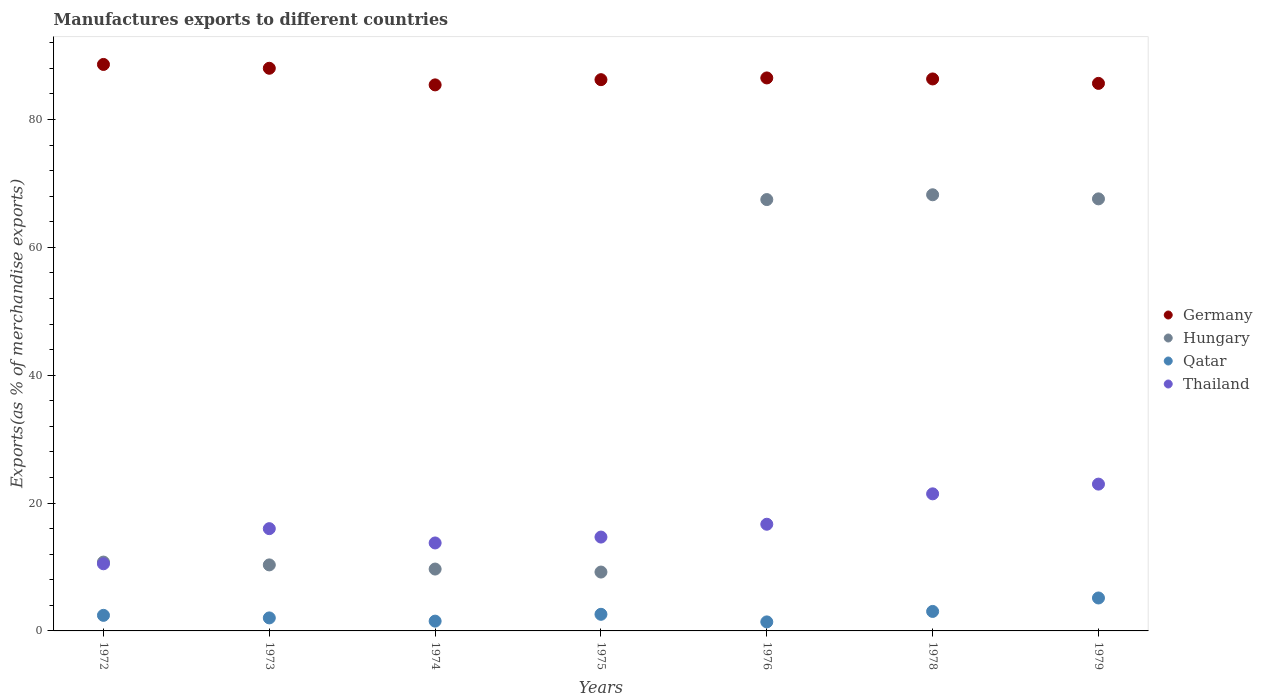Is the number of dotlines equal to the number of legend labels?
Provide a succinct answer. Yes. What is the percentage of exports to different countries in Hungary in 1978?
Ensure brevity in your answer.  68.23. Across all years, what is the maximum percentage of exports to different countries in Thailand?
Make the answer very short. 22.96. Across all years, what is the minimum percentage of exports to different countries in Thailand?
Make the answer very short. 10.5. In which year was the percentage of exports to different countries in Thailand maximum?
Your answer should be very brief. 1979. In which year was the percentage of exports to different countries in Germany minimum?
Your response must be concise. 1974. What is the total percentage of exports to different countries in Hungary in the graph?
Make the answer very short. 243.27. What is the difference between the percentage of exports to different countries in Thailand in 1972 and that in 1976?
Offer a very short reply. -6.18. What is the difference between the percentage of exports to different countries in Qatar in 1976 and the percentage of exports to different countries in Germany in 1974?
Provide a short and direct response. -84.01. What is the average percentage of exports to different countries in Thailand per year?
Make the answer very short. 16.58. In the year 1973, what is the difference between the percentage of exports to different countries in Thailand and percentage of exports to different countries in Germany?
Ensure brevity in your answer.  -72.02. What is the ratio of the percentage of exports to different countries in Hungary in 1972 to that in 1978?
Offer a terse response. 0.16. Is the percentage of exports to different countries in Hungary in 1973 less than that in 1978?
Your response must be concise. Yes. Is the difference between the percentage of exports to different countries in Thailand in 1973 and 1974 greater than the difference between the percentage of exports to different countries in Germany in 1973 and 1974?
Your response must be concise. No. What is the difference between the highest and the second highest percentage of exports to different countries in Thailand?
Keep it short and to the point. 1.52. What is the difference between the highest and the lowest percentage of exports to different countries in Hungary?
Your answer should be very brief. 59.02. In how many years, is the percentage of exports to different countries in Germany greater than the average percentage of exports to different countries in Germany taken over all years?
Your answer should be compact. 2. Is it the case that in every year, the sum of the percentage of exports to different countries in Thailand and percentage of exports to different countries in Germany  is greater than the sum of percentage of exports to different countries in Hungary and percentage of exports to different countries in Qatar?
Your answer should be very brief. No. Is the percentage of exports to different countries in Germany strictly greater than the percentage of exports to different countries in Qatar over the years?
Your answer should be very brief. Yes. What is the difference between two consecutive major ticks on the Y-axis?
Provide a short and direct response. 20. Are the values on the major ticks of Y-axis written in scientific E-notation?
Offer a terse response. No. Does the graph contain grids?
Provide a succinct answer. No. How many legend labels are there?
Keep it short and to the point. 4. How are the legend labels stacked?
Offer a very short reply. Vertical. What is the title of the graph?
Provide a short and direct response. Manufactures exports to different countries. Does "Greenland" appear as one of the legend labels in the graph?
Keep it short and to the point. No. What is the label or title of the X-axis?
Your response must be concise. Years. What is the label or title of the Y-axis?
Offer a very short reply. Exports(as % of merchandise exports). What is the Exports(as % of merchandise exports) of Germany in 1972?
Offer a terse response. 88.61. What is the Exports(as % of merchandise exports) in Hungary in 1972?
Offer a very short reply. 10.77. What is the Exports(as % of merchandise exports) of Qatar in 1972?
Keep it short and to the point. 2.44. What is the Exports(as % of merchandise exports) in Thailand in 1972?
Ensure brevity in your answer.  10.5. What is the Exports(as % of merchandise exports) of Germany in 1973?
Provide a short and direct response. 88.02. What is the Exports(as % of merchandise exports) in Hungary in 1973?
Provide a succinct answer. 10.33. What is the Exports(as % of merchandise exports) in Qatar in 1973?
Give a very brief answer. 2.04. What is the Exports(as % of merchandise exports) in Thailand in 1973?
Offer a terse response. 16. What is the Exports(as % of merchandise exports) in Germany in 1974?
Keep it short and to the point. 85.42. What is the Exports(as % of merchandise exports) in Hungary in 1974?
Your answer should be compact. 9.68. What is the Exports(as % of merchandise exports) in Qatar in 1974?
Provide a short and direct response. 1.53. What is the Exports(as % of merchandise exports) in Thailand in 1974?
Make the answer very short. 13.76. What is the Exports(as % of merchandise exports) of Germany in 1975?
Offer a terse response. 86.23. What is the Exports(as % of merchandise exports) of Hungary in 1975?
Keep it short and to the point. 9.21. What is the Exports(as % of merchandise exports) of Qatar in 1975?
Your answer should be compact. 2.6. What is the Exports(as % of merchandise exports) in Thailand in 1975?
Your answer should be very brief. 14.68. What is the Exports(as % of merchandise exports) of Germany in 1976?
Provide a short and direct response. 86.5. What is the Exports(as % of merchandise exports) in Hungary in 1976?
Offer a very short reply. 67.48. What is the Exports(as % of merchandise exports) of Qatar in 1976?
Your response must be concise. 1.41. What is the Exports(as % of merchandise exports) in Thailand in 1976?
Make the answer very short. 16.69. What is the Exports(as % of merchandise exports) of Germany in 1978?
Keep it short and to the point. 86.35. What is the Exports(as % of merchandise exports) in Hungary in 1978?
Offer a very short reply. 68.23. What is the Exports(as % of merchandise exports) of Qatar in 1978?
Provide a succinct answer. 3.05. What is the Exports(as % of merchandise exports) of Thailand in 1978?
Offer a very short reply. 21.44. What is the Exports(as % of merchandise exports) in Germany in 1979?
Offer a very short reply. 85.65. What is the Exports(as % of merchandise exports) of Hungary in 1979?
Provide a succinct answer. 67.59. What is the Exports(as % of merchandise exports) in Qatar in 1979?
Provide a succinct answer. 5.15. What is the Exports(as % of merchandise exports) of Thailand in 1979?
Give a very brief answer. 22.96. Across all years, what is the maximum Exports(as % of merchandise exports) in Germany?
Provide a succinct answer. 88.61. Across all years, what is the maximum Exports(as % of merchandise exports) of Hungary?
Keep it short and to the point. 68.23. Across all years, what is the maximum Exports(as % of merchandise exports) in Qatar?
Your response must be concise. 5.15. Across all years, what is the maximum Exports(as % of merchandise exports) in Thailand?
Offer a very short reply. 22.96. Across all years, what is the minimum Exports(as % of merchandise exports) in Germany?
Provide a succinct answer. 85.42. Across all years, what is the minimum Exports(as % of merchandise exports) in Hungary?
Make the answer very short. 9.21. Across all years, what is the minimum Exports(as % of merchandise exports) of Qatar?
Give a very brief answer. 1.41. Across all years, what is the minimum Exports(as % of merchandise exports) in Thailand?
Your answer should be very brief. 10.5. What is the total Exports(as % of merchandise exports) of Germany in the graph?
Offer a terse response. 606.78. What is the total Exports(as % of merchandise exports) of Hungary in the graph?
Offer a very short reply. 243.27. What is the total Exports(as % of merchandise exports) of Qatar in the graph?
Provide a succinct answer. 18.21. What is the total Exports(as % of merchandise exports) in Thailand in the graph?
Ensure brevity in your answer.  116.04. What is the difference between the Exports(as % of merchandise exports) in Germany in 1972 and that in 1973?
Provide a succinct answer. 0.6. What is the difference between the Exports(as % of merchandise exports) in Hungary in 1972 and that in 1973?
Make the answer very short. 0.44. What is the difference between the Exports(as % of merchandise exports) in Qatar in 1972 and that in 1973?
Your answer should be very brief. 0.4. What is the difference between the Exports(as % of merchandise exports) of Thailand in 1972 and that in 1973?
Offer a terse response. -5.5. What is the difference between the Exports(as % of merchandise exports) of Germany in 1972 and that in 1974?
Keep it short and to the point. 3.2. What is the difference between the Exports(as % of merchandise exports) in Hungary in 1972 and that in 1974?
Ensure brevity in your answer.  1.09. What is the difference between the Exports(as % of merchandise exports) of Qatar in 1972 and that in 1974?
Make the answer very short. 0.9. What is the difference between the Exports(as % of merchandise exports) in Thailand in 1972 and that in 1974?
Your answer should be very brief. -3.26. What is the difference between the Exports(as % of merchandise exports) in Germany in 1972 and that in 1975?
Give a very brief answer. 2.38. What is the difference between the Exports(as % of merchandise exports) of Hungary in 1972 and that in 1975?
Ensure brevity in your answer.  1.56. What is the difference between the Exports(as % of merchandise exports) in Qatar in 1972 and that in 1975?
Make the answer very short. -0.16. What is the difference between the Exports(as % of merchandise exports) of Thailand in 1972 and that in 1975?
Your answer should be compact. -4.18. What is the difference between the Exports(as % of merchandise exports) of Germany in 1972 and that in 1976?
Keep it short and to the point. 2.11. What is the difference between the Exports(as % of merchandise exports) of Hungary in 1972 and that in 1976?
Your response must be concise. -56.71. What is the difference between the Exports(as % of merchandise exports) in Qatar in 1972 and that in 1976?
Provide a short and direct response. 1.02. What is the difference between the Exports(as % of merchandise exports) in Thailand in 1972 and that in 1976?
Provide a succinct answer. -6.18. What is the difference between the Exports(as % of merchandise exports) of Germany in 1972 and that in 1978?
Keep it short and to the point. 2.27. What is the difference between the Exports(as % of merchandise exports) in Hungary in 1972 and that in 1978?
Make the answer very short. -57.46. What is the difference between the Exports(as % of merchandise exports) in Qatar in 1972 and that in 1978?
Make the answer very short. -0.61. What is the difference between the Exports(as % of merchandise exports) in Thailand in 1972 and that in 1978?
Offer a terse response. -10.94. What is the difference between the Exports(as % of merchandise exports) in Germany in 1972 and that in 1979?
Your answer should be very brief. 2.96. What is the difference between the Exports(as % of merchandise exports) in Hungary in 1972 and that in 1979?
Offer a terse response. -56.82. What is the difference between the Exports(as % of merchandise exports) in Qatar in 1972 and that in 1979?
Give a very brief answer. -2.72. What is the difference between the Exports(as % of merchandise exports) in Thailand in 1972 and that in 1979?
Your answer should be very brief. -12.46. What is the difference between the Exports(as % of merchandise exports) in Germany in 1973 and that in 1974?
Offer a terse response. 2.6. What is the difference between the Exports(as % of merchandise exports) in Hungary in 1973 and that in 1974?
Provide a succinct answer. 0.65. What is the difference between the Exports(as % of merchandise exports) of Qatar in 1973 and that in 1974?
Ensure brevity in your answer.  0.5. What is the difference between the Exports(as % of merchandise exports) in Thailand in 1973 and that in 1974?
Ensure brevity in your answer.  2.24. What is the difference between the Exports(as % of merchandise exports) of Germany in 1973 and that in 1975?
Your response must be concise. 1.78. What is the difference between the Exports(as % of merchandise exports) of Hungary in 1973 and that in 1975?
Make the answer very short. 1.12. What is the difference between the Exports(as % of merchandise exports) in Qatar in 1973 and that in 1975?
Provide a succinct answer. -0.56. What is the difference between the Exports(as % of merchandise exports) of Thailand in 1973 and that in 1975?
Keep it short and to the point. 1.32. What is the difference between the Exports(as % of merchandise exports) of Germany in 1973 and that in 1976?
Your response must be concise. 1.51. What is the difference between the Exports(as % of merchandise exports) in Hungary in 1973 and that in 1976?
Your answer should be compact. -57.15. What is the difference between the Exports(as % of merchandise exports) of Qatar in 1973 and that in 1976?
Make the answer very short. 0.62. What is the difference between the Exports(as % of merchandise exports) in Thailand in 1973 and that in 1976?
Offer a very short reply. -0.69. What is the difference between the Exports(as % of merchandise exports) in Germany in 1973 and that in 1978?
Keep it short and to the point. 1.67. What is the difference between the Exports(as % of merchandise exports) of Hungary in 1973 and that in 1978?
Your answer should be very brief. -57.9. What is the difference between the Exports(as % of merchandise exports) of Qatar in 1973 and that in 1978?
Your answer should be compact. -1.01. What is the difference between the Exports(as % of merchandise exports) in Thailand in 1973 and that in 1978?
Offer a very short reply. -5.45. What is the difference between the Exports(as % of merchandise exports) in Germany in 1973 and that in 1979?
Your answer should be compact. 2.36. What is the difference between the Exports(as % of merchandise exports) of Hungary in 1973 and that in 1979?
Make the answer very short. -57.26. What is the difference between the Exports(as % of merchandise exports) of Qatar in 1973 and that in 1979?
Offer a terse response. -3.12. What is the difference between the Exports(as % of merchandise exports) of Thailand in 1973 and that in 1979?
Offer a terse response. -6.97. What is the difference between the Exports(as % of merchandise exports) in Germany in 1974 and that in 1975?
Ensure brevity in your answer.  -0.81. What is the difference between the Exports(as % of merchandise exports) of Hungary in 1974 and that in 1975?
Provide a succinct answer. 0.47. What is the difference between the Exports(as % of merchandise exports) of Qatar in 1974 and that in 1975?
Offer a terse response. -1.07. What is the difference between the Exports(as % of merchandise exports) of Thailand in 1974 and that in 1975?
Your answer should be very brief. -0.92. What is the difference between the Exports(as % of merchandise exports) of Germany in 1974 and that in 1976?
Keep it short and to the point. -1.09. What is the difference between the Exports(as % of merchandise exports) in Hungary in 1974 and that in 1976?
Ensure brevity in your answer.  -57.8. What is the difference between the Exports(as % of merchandise exports) of Qatar in 1974 and that in 1976?
Your response must be concise. 0.12. What is the difference between the Exports(as % of merchandise exports) of Thailand in 1974 and that in 1976?
Your answer should be very brief. -2.93. What is the difference between the Exports(as % of merchandise exports) in Germany in 1974 and that in 1978?
Provide a short and direct response. -0.93. What is the difference between the Exports(as % of merchandise exports) of Hungary in 1974 and that in 1978?
Provide a succinct answer. -58.55. What is the difference between the Exports(as % of merchandise exports) in Qatar in 1974 and that in 1978?
Offer a very short reply. -1.52. What is the difference between the Exports(as % of merchandise exports) of Thailand in 1974 and that in 1978?
Offer a terse response. -7.68. What is the difference between the Exports(as % of merchandise exports) of Germany in 1974 and that in 1979?
Provide a succinct answer. -0.23. What is the difference between the Exports(as % of merchandise exports) in Hungary in 1974 and that in 1979?
Provide a short and direct response. -57.91. What is the difference between the Exports(as % of merchandise exports) in Qatar in 1974 and that in 1979?
Provide a succinct answer. -3.62. What is the difference between the Exports(as % of merchandise exports) in Thailand in 1974 and that in 1979?
Ensure brevity in your answer.  -9.2. What is the difference between the Exports(as % of merchandise exports) of Germany in 1975 and that in 1976?
Ensure brevity in your answer.  -0.27. What is the difference between the Exports(as % of merchandise exports) of Hungary in 1975 and that in 1976?
Give a very brief answer. -58.27. What is the difference between the Exports(as % of merchandise exports) of Qatar in 1975 and that in 1976?
Your response must be concise. 1.19. What is the difference between the Exports(as % of merchandise exports) in Thailand in 1975 and that in 1976?
Your response must be concise. -2.01. What is the difference between the Exports(as % of merchandise exports) in Germany in 1975 and that in 1978?
Provide a succinct answer. -0.11. What is the difference between the Exports(as % of merchandise exports) in Hungary in 1975 and that in 1978?
Keep it short and to the point. -59.02. What is the difference between the Exports(as % of merchandise exports) in Qatar in 1975 and that in 1978?
Offer a very short reply. -0.45. What is the difference between the Exports(as % of merchandise exports) of Thailand in 1975 and that in 1978?
Your response must be concise. -6.76. What is the difference between the Exports(as % of merchandise exports) of Germany in 1975 and that in 1979?
Provide a short and direct response. 0.58. What is the difference between the Exports(as % of merchandise exports) in Hungary in 1975 and that in 1979?
Give a very brief answer. -58.38. What is the difference between the Exports(as % of merchandise exports) in Qatar in 1975 and that in 1979?
Offer a terse response. -2.55. What is the difference between the Exports(as % of merchandise exports) in Thailand in 1975 and that in 1979?
Keep it short and to the point. -8.28. What is the difference between the Exports(as % of merchandise exports) of Germany in 1976 and that in 1978?
Offer a terse response. 0.16. What is the difference between the Exports(as % of merchandise exports) in Hungary in 1976 and that in 1978?
Offer a terse response. -0.75. What is the difference between the Exports(as % of merchandise exports) in Qatar in 1976 and that in 1978?
Offer a terse response. -1.64. What is the difference between the Exports(as % of merchandise exports) of Thailand in 1976 and that in 1978?
Offer a very short reply. -4.76. What is the difference between the Exports(as % of merchandise exports) in Germany in 1976 and that in 1979?
Your answer should be compact. 0.85. What is the difference between the Exports(as % of merchandise exports) of Hungary in 1976 and that in 1979?
Your response must be concise. -0.11. What is the difference between the Exports(as % of merchandise exports) of Qatar in 1976 and that in 1979?
Provide a succinct answer. -3.74. What is the difference between the Exports(as % of merchandise exports) of Thailand in 1976 and that in 1979?
Provide a succinct answer. -6.28. What is the difference between the Exports(as % of merchandise exports) in Germany in 1978 and that in 1979?
Offer a very short reply. 0.69. What is the difference between the Exports(as % of merchandise exports) in Hungary in 1978 and that in 1979?
Your response must be concise. 0.64. What is the difference between the Exports(as % of merchandise exports) in Qatar in 1978 and that in 1979?
Provide a succinct answer. -2.1. What is the difference between the Exports(as % of merchandise exports) of Thailand in 1978 and that in 1979?
Your answer should be very brief. -1.52. What is the difference between the Exports(as % of merchandise exports) in Germany in 1972 and the Exports(as % of merchandise exports) in Hungary in 1973?
Your answer should be very brief. 78.29. What is the difference between the Exports(as % of merchandise exports) of Germany in 1972 and the Exports(as % of merchandise exports) of Qatar in 1973?
Provide a short and direct response. 86.58. What is the difference between the Exports(as % of merchandise exports) of Germany in 1972 and the Exports(as % of merchandise exports) of Thailand in 1973?
Keep it short and to the point. 72.62. What is the difference between the Exports(as % of merchandise exports) of Hungary in 1972 and the Exports(as % of merchandise exports) of Qatar in 1973?
Give a very brief answer. 8.73. What is the difference between the Exports(as % of merchandise exports) in Hungary in 1972 and the Exports(as % of merchandise exports) in Thailand in 1973?
Your response must be concise. -5.23. What is the difference between the Exports(as % of merchandise exports) in Qatar in 1972 and the Exports(as % of merchandise exports) in Thailand in 1973?
Give a very brief answer. -13.56. What is the difference between the Exports(as % of merchandise exports) in Germany in 1972 and the Exports(as % of merchandise exports) in Hungary in 1974?
Your response must be concise. 78.94. What is the difference between the Exports(as % of merchandise exports) in Germany in 1972 and the Exports(as % of merchandise exports) in Qatar in 1974?
Offer a very short reply. 87.08. What is the difference between the Exports(as % of merchandise exports) in Germany in 1972 and the Exports(as % of merchandise exports) in Thailand in 1974?
Make the answer very short. 74.85. What is the difference between the Exports(as % of merchandise exports) of Hungary in 1972 and the Exports(as % of merchandise exports) of Qatar in 1974?
Give a very brief answer. 9.24. What is the difference between the Exports(as % of merchandise exports) of Hungary in 1972 and the Exports(as % of merchandise exports) of Thailand in 1974?
Provide a short and direct response. -2.99. What is the difference between the Exports(as % of merchandise exports) of Qatar in 1972 and the Exports(as % of merchandise exports) of Thailand in 1974?
Ensure brevity in your answer.  -11.32. What is the difference between the Exports(as % of merchandise exports) in Germany in 1972 and the Exports(as % of merchandise exports) in Hungary in 1975?
Provide a succinct answer. 79.41. What is the difference between the Exports(as % of merchandise exports) of Germany in 1972 and the Exports(as % of merchandise exports) of Qatar in 1975?
Ensure brevity in your answer.  86.02. What is the difference between the Exports(as % of merchandise exports) of Germany in 1972 and the Exports(as % of merchandise exports) of Thailand in 1975?
Make the answer very short. 73.93. What is the difference between the Exports(as % of merchandise exports) in Hungary in 1972 and the Exports(as % of merchandise exports) in Qatar in 1975?
Keep it short and to the point. 8.17. What is the difference between the Exports(as % of merchandise exports) in Hungary in 1972 and the Exports(as % of merchandise exports) in Thailand in 1975?
Ensure brevity in your answer.  -3.91. What is the difference between the Exports(as % of merchandise exports) of Qatar in 1972 and the Exports(as % of merchandise exports) of Thailand in 1975?
Your response must be concise. -12.25. What is the difference between the Exports(as % of merchandise exports) of Germany in 1972 and the Exports(as % of merchandise exports) of Hungary in 1976?
Your answer should be compact. 21.14. What is the difference between the Exports(as % of merchandise exports) of Germany in 1972 and the Exports(as % of merchandise exports) of Qatar in 1976?
Your answer should be very brief. 87.2. What is the difference between the Exports(as % of merchandise exports) in Germany in 1972 and the Exports(as % of merchandise exports) in Thailand in 1976?
Provide a short and direct response. 71.93. What is the difference between the Exports(as % of merchandise exports) in Hungary in 1972 and the Exports(as % of merchandise exports) in Qatar in 1976?
Provide a succinct answer. 9.36. What is the difference between the Exports(as % of merchandise exports) in Hungary in 1972 and the Exports(as % of merchandise exports) in Thailand in 1976?
Ensure brevity in your answer.  -5.92. What is the difference between the Exports(as % of merchandise exports) in Qatar in 1972 and the Exports(as % of merchandise exports) in Thailand in 1976?
Make the answer very short. -14.25. What is the difference between the Exports(as % of merchandise exports) of Germany in 1972 and the Exports(as % of merchandise exports) of Hungary in 1978?
Your answer should be compact. 20.39. What is the difference between the Exports(as % of merchandise exports) of Germany in 1972 and the Exports(as % of merchandise exports) of Qatar in 1978?
Give a very brief answer. 85.56. What is the difference between the Exports(as % of merchandise exports) of Germany in 1972 and the Exports(as % of merchandise exports) of Thailand in 1978?
Provide a succinct answer. 67.17. What is the difference between the Exports(as % of merchandise exports) in Hungary in 1972 and the Exports(as % of merchandise exports) in Qatar in 1978?
Provide a succinct answer. 7.72. What is the difference between the Exports(as % of merchandise exports) in Hungary in 1972 and the Exports(as % of merchandise exports) in Thailand in 1978?
Your answer should be compact. -10.68. What is the difference between the Exports(as % of merchandise exports) of Qatar in 1972 and the Exports(as % of merchandise exports) of Thailand in 1978?
Your response must be concise. -19.01. What is the difference between the Exports(as % of merchandise exports) in Germany in 1972 and the Exports(as % of merchandise exports) in Hungary in 1979?
Offer a terse response. 21.03. What is the difference between the Exports(as % of merchandise exports) of Germany in 1972 and the Exports(as % of merchandise exports) of Qatar in 1979?
Give a very brief answer. 83.46. What is the difference between the Exports(as % of merchandise exports) in Germany in 1972 and the Exports(as % of merchandise exports) in Thailand in 1979?
Your response must be concise. 65.65. What is the difference between the Exports(as % of merchandise exports) in Hungary in 1972 and the Exports(as % of merchandise exports) in Qatar in 1979?
Keep it short and to the point. 5.61. What is the difference between the Exports(as % of merchandise exports) of Hungary in 1972 and the Exports(as % of merchandise exports) of Thailand in 1979?
Provide a succinct answer. -12.2. What is the difference between the Exports(as % of merchandise exports) of Qatar in 1972 and the Exports(as % of merchandise exports) of Thailand in 1979?
Your answer should be compact. -20.53. What is the difference between the Exports(as % of merchandise exports) in Germany in 1973 and the Exports(as % of merchandise exports) in Hungary in 1974?
Make the answer very short. 78.34. What is the difference between the Exports(as % of merchandise exports) of Germany in 1973 and the Exports(as % of merchandise exports) of Qatar in 1974?
Offer a very short reply. 86.48. What is the difference between the Exports(as % of merchandise exports) of Germany in 1973 and the Exports(as % of merchandise exports) of Thailand in 1974?
Your answer should be compact. 74.26. What is the difference between the Exports(as % of merchandise exports) of Hungary in 1973 and the Exports(as % of merchandise exports) of Qatar in 1974?
Offer a terse response. 8.8. What is the difference between the Exports(as % of merchandise exports) in Hungary in 1973 and the Exports(as % of merchandise exports) in Thailand in 1974?
Keep it short and to the point. -3.43. What is the difference between the Exports(as % of merchandise exports) of Qatar in 1973 and the Exports(as % of merchandise exports) of Thailand in 1974?
Keep it short and to the point. -11.72. What is the difference between the Exports(as % of merchandise exports) of Germany in 1973 and the Exports(as % of merchandise exports) of Hungary in 1975?
Provide a succinct answer. 78.81. What is the difference between the Exports(as % of merchandise exports) in Germany in 1973 and the Exports(as % of merchandise exports) in Qatar in 1975?
Your answer should be very brief. 85.42. What is the difference between the Exports(as % of merchandise exports) in Germany in 1973 and the Exports(as % of merchandise exports) in Thailand in 1975?
Offer a very short reply. 73.33. What is the difference between the Exports(as % of merchandise exports) in Hungary in 1973 and the Exports(as % of merchandise exports) in Qatar in 1975?
Give a very brief answer. 7.73. What is the difference between the Exports(as % of merchandise exports) of Hungary in 1973 and the Exports(as % of merchandise exports) of Thailand in 1975?
Offer a very short reply. -4.35. What is the difference between the Exports(as % of merchandise exports) of Qatar in 1973 and the Exports(as % of merchandise exports) of Thailand in 1975?
Make the answer very short. -12.65. What is the difference between the Exports(as % of merchandise exports) in Germany in 1973 and the Exports(as % of merchandise exports) in Hungary in 1976?
Ensure brevity in your answer.  20.54. What is the difference between the Exports(as % of merchandise exports) of Germany in 1973 and the Exports(as % of merchandise exports) of Qatar in 1976?
Provide a short and direct response. 86.61. What is the difference between the Exports(as % of merchandise exports) of Germany in 1973 and the Exports(as % of merchandise exports) of Thailand in 1976?
Your response must be concise. 71.33. What is the difference between the Exports(as % of merchandise exports) of Hungary in 1973 and the Exports(as % of merchandise exports) of Qatar in 1976?
Keep it short and to the point. 8.92. What is the difference between the Exports(as % of merchandise exports) in Hungary in 1973 and the Exports(as % of merchandise exports) in Thailand in 1976?
Offer a terse response. -6.36. What is the difference between the Exports(as % of merchandise exports) in Qatar in 1973 and the Exports(as % of merchandise exports) in Thailand in 1976?
Provide a succinct answer. -14.65. What is the difference between the Exports(as % of merchandise exports) of Germany in 1973 and the Exports(as % of merchandise exports) of Hungary in 1978?
Your response must be concise. 19.79. What is the difference between the Exports(as % of merchandise exports) in Germany in 1973 and the Exports(as % of merchandise exports) in Qatar in 1978?
Your response must be concise. 84.97. What is the difference between the Exports(as % of merchandise exports) in Germany in 1973 and the Exports(as % of merchandise exports) in Thailand in 1978?
Your answer should be compact. 66.57. What is the difference between the Exports(as % of merchandise exports) in Hungary in 1973 and the Exports(as % of merchandise exports) in Qatar in 1978?
Ensure brevity in your answer.  7.28. What is the difference between the Exports(as % of merchandise exports) in Hungary in 1973 and the Exports(as % of merchandise exports) in Thailand in 1978?
Offer a very short reply. -11.12. What is the difference between the Exports(as % of merchandise exports) in Qatar in 1973 and the Exports(as % of merchandise exports) in Thailand in 1978?
Your answer should be very brief. -19.41. What is the difference between the Exports(as % of merchandise exports) in Germany in 1973 and the Exports(as % of merchandise exports) in Hungary in 1979?
Provide a succinct answer. 20.43. What is the difference between the Exports(as % of merchandise exports) of Germany in 1973 and the Exports(as % of merchandise exports) of Qatar in 1979?
Provide a succinct answer. 82.86. What is the difference between the Exports(as % of merchandise exports) of Germany in 1973 and the Exports(as % of merchandise exports) of Thailand in 1979?
Your answer should be compact. 65.05. What is the difference between the Exports(as % of merchandise exports) of Hungary in 1973 and the Exports(as % of merchandise exports) of Qatar in 1979?
Offer a terse response. 5.18. What is the difference between the Exports(as % of merchandise exports) in Hungary in 1973 and the Exports(as % of merchandise exports) in Thailand in 1979?
Your answer should be compact. -12.64. What is the difference between the Exports(as % of merchandise exports) in Qatar in 1973 and the Exports(as % of merchandise exports) in Thailand in 1979?
Make the answer very short. -20.93. What is the difference between the Exports(as % of merchandise exports) of Germany in 1974 and the Exports(as % of merchandise exports) of Hungary in 1975?
Ensure brevity in your answer.  76.21. What is the difference between the Exports(as % of merchandise exports) of Germany in 1974 and the Exports(as % of merchandise exports) of Qatar in 1975?
Ensure brevity in your answer.  82.82. What is the difference between the Exports(as % of merchandise exports) in Germany in 1974 and the Exports(as % of merchandise exports) in Thailand in 1975?
Keep it short and to the point. 70.74. What is the difference between the Exports(as % of merchandise exports) of Hungary in 1974 and the Exports(as % of merchandise exports) of Qatar in 1975?
Make the answer very short. 7.08. What is the difference between the Exports(as % of merchandise exports) of Hungary in 1974 and the Exports(as % of merchandise exports) of Thailand in 1975?
Ensure brevity in your answer.  -5. What is the difference between the Exports(as % of merchandise exports) of Qatar in 1974 and the Exports(as % of merchandise exports) of Thailand in 1975?
Keep it short and to the point. -13.15. What is the difference between the Exports(as % of merchandise exports) of Germany in 1974 and the Exports(as % of merchandise exports) of Hungary in 1976?
Provide a succinct answer. 17.94. What is the difference between the Exports(as % of merchandise exports) in Germany in 1974 and the Exports(as % of merchandise exports) in Qatar in 1976?
Offer a terse response. 84.01. What is the difference between the Exports(as % of merchandise exports) in Germany in 1974 and the Exports(as % of merchandise exports) in Thailand in 1976?
Your response must be concise. 68.73. What is the difference between the Exports(as % of merchandise exports) in Hungary in 1974 and the Exports(as % of merchandise exports) in Qatar in 1976?
Offer a terse response. 8.27. What is the difference between the Exports(as % of merchandise exports) in Hungary in 1974 and the Exports(as % of merchandise exports) in Thailand in 1976?
Give a very brief answer. -7.01. What is the difference between the Exports(as % of merchandise exports) of Qatar in 1974 and the Exports(as % of merchandise exports) of Thailand in 1976?
Ensure brevity in your answer.  -15.16. What is the difference between the Exports(as % of merchandise exports) in Germany in 1974 and the Exports(as % of merchandise exports) in Hungary in 1978?
Your answer should be very brief. 17.19. What is the difference between the Exports(as % of merchandise exports) in Germany in 1974 and the Exports(as % of merchandise exports) in Qatar in 1978?
Make the answer very short. 82.37. What is the difference between the Exports(as % of merchandise exports) in Germany in 1974 and the Exports(as % of merchandise exports) in Thailand in 1978?
Keep it short and to the point. 63.97. What is the difference between the Exports(as % of merchandise exports) of Hungary in 1974 and the Exports(as % of merchandise exports) of Qatar in 1978?
Your response must be concise. 6.63. What is the difference between the Exports(as % of merchandise exports) in Hungary in 1974 and the Exports(as % of merchandise exports) in Thailand in 1978?
Provide a succinct answer. -11.77. What is the difference between the Exports(as % of merchandise exports) of Qatar in 1974 and the Exports(as % of merchandise exports) of Thailand in 1978?
Offer a very short reply. -19.91. What is the difference between the Exports(as % of merchandise exports) of Germany in 1974 and the Exports(as % of merchandise exports) of Hungary in 1979?
Give a very brief answer. 17.83. What is the difference between the Exports(as % of merchandise exports) in Germany in 1974 and the Exports(as % of merchandise exports) in Qatar in 1979?
Make the answer very short. 80.26. What is the difference between the Exports(as % of merchandise exports) of Germany in 1974 and the Exports(as % of merchandise exports) of Thailand in 1979?
Offer a terse response. 62.45. What is the difference between the Exports(as % of merchandise exports) in Hungary in 1974 and the Exports(as % of merchandise exports) in Qatar in 1979?
Give a very brief answer. 4.53. What is the difference between the Exports(as % of merchandise exports) of Hungary in 1974 and the Exports(as % of merchandise exports) of Thailand in 1979?
Give a very brief answer. -13.29. What is the difference between the Exports(as % of merchandise exports) in Qatar in 1974 and the Exports(as % of merchandise exports) in Thailand in 1979?
Ensure brevity in your answer.  -21.43. What is the difference between the Exports(as % of merchandise exports) in Germany in 1975 and the Exports(as % of merchandise exports) in Hungary in 1976?
Your answer should be very brief. 18.76. What is the difference between the Exports(as % of merchandise exports) in Germany in 1975 and the Exports(as % of merchandise exports) in Qatar in 1976?
Keep it short and to the point. 84.82. What is the difference between the Exports(as % of merchandise exports) of Germany in 1975 and the Exports(as % of merchandise exports) of Thailand in 1976?
Keep it short and to the point. 69.55. What is the difference between the Exports(as % of merchandise exports) of Hungary in 1975 and the Exports(as % of merchandise exports) of Qatar in 1976?
Your answer should be very brief. 7.8. What is the difference between the Exports(as % of merchandise exports) of Hungary in 1975 and the Exports(as % of merchandise exports) of Thailand in 1976?
Ensure brevity in your answer.  -7.48. What is the difference between the Exports(as % of merchandise exports) in Qatar in 1975 and the Exports(as % of merchandise exports) in Thailand in 1976?
Your answer should be compact. -14.09. What is the difference between the Exports(as % of merchandise exports) of Germany in 1975 and the Exports(as % of merchandise exports) of Hungary in 1978?
Your response must be concise. 18. What is the difference between the Exports(as % of merchandise exports) of Germany in 1975 and the Exports(as % of merchandise exports) of Qatar in 1978?
Ensure brevity in your answer.  83.18. What is the difference between the Exports(as % of merchandise exports) in Germany in 1975 and the Exports(as % of merchandise exports) in Thailand in 1978?
Make the answer very short. 64.79. What is the difference between the Exports(as % of merchandise exports) in Hungary in 1975 and the Exports(as % of merchandise exports) in Qatar in 1978?
Provide a short and direct response. 6.16. What is the difference between the Exports(as % of merchandise exports) in Hungary in 1975 and the Exports(as % of merchandise exports) in Thailand in 1978?
Your answer should be compact. -12.24. What is the difference between the Exports(as % of merchandise exports) of Qatar in 1975 and the Exports(as % of merchandise exports) of Thailand in 1978?
Give a very brief answer. -18.85. What is the difference between the Exports(as % of merchandise exports) of Germany in 1975 and the Exports(as % of merchandise exports) of Hungary in 1979?
Provide a succinct answer. 18.65. What is the difference between the Exports(as % of merchandise exports) of Germany in 1975 and the Exports(as % of merchandise exports) of Qatar in 1979?
Make the answer very short. 81.08. What is the difference between the Exports(as % of merchandise exports) in Germany in 1975 and the Exports(as % of merchandise exports) in Thailand in 1979?
Give a very brief answer. 63.27. What is the difference between the Exports(as % of merchandise exports) in Hungary in 1975 and the Exports(as % of merchandise exports) in Qatar in 1979?
Provide a succinct answer. 4.06. What is the difference between the Exports(as % of merchandise exports) in Hungary in 1975 and the Exports(as % of merchandise exports) in Thailand in 1979?
Keep it short and to the point. -13.76. What is the difference between the Exports(as % of merchandise exports) of Qatar in 1975 and the Exports(as % of merchandise exports) of Thailand in 1979?
Your response must be concise. -20.37. What is the difference between the Exports(as % of merchandise exports) of Germany in 1976 and the Exports(as % of merchandise exports) of Hungary in 1978?
Keep it short and to the point. 18.28. What is the difference between the Exports(as % of merchandise exports) in Germany in 1976 and the Exports(as % of merchandise exports) in Qatar in 1978?
Your response must be concise. 83.45. What is the difference between the Exports(as % of merchandise exports) in Germany in 1976 and the Exports(as % of merchandise exports) in Thailand in 1978?
Offer a terse response. 65.06. What is the difference between the Exports(as % of merchandise exports) of Hungary in 1976 and the Exports(as % of merchandise exports) of Qatar in 1978?
Provide a short and direct response. 64.43. What is the difference between the Exports(as % of merchandise exports) of Hungary in 1976 and the Exports(as % of merchandise exports) of Thailand in 1978?
Your response must be concise. 46.03. What is the difference between the Exports(as % of merchandise exports) in Qatar in 1976 and the Exports(as % of merchandise exports) in Thailand in 1978?
Keep it short and to the point. -20.03. What is the difference between the Exports(as % of merchandise exports) in Germany in 1976 and the Exports(as % of merchandise exports) in Hungary in 1979?
Ensure brevity in your answer.  18.92. What is the difference between the Exports(as % of merchandise exports) in Germany in 1976 and the Exports(as % of merchandise exports) in Qatar in 1979?
Ensure brevity in your answer.  81.35. What is the difference between the Exports(as % of merchandise exports) of Germany in 1976 and the Exports(as % of merchandise exports) of Thailand in 1979?
Give a very brief answer. 63.54. What is the difference between the Exports(as % of merchandise exports) of Hungary in 1976 and the Exports(as % of merchandise exports) of Qatar in 1979?
Give a very brief answer. 62.32. What is the difference between the Exports(as % of merchandise exports) of Hungary in 1976 and the Exports(as % of merchandise exports) of Thailand in 1979?
Make the answer very short. 44.51. What is the difference between the Exports(as % of merchandise exports) in Qatar in 1976 and the Exports(as % of merchandise exports) in Thailand in 1979?
Your answer should be very brief. -21.55. What is the difference between the Exports(as % of merchandise exports) of Germany in 1978 and the Exports(as % of merchandise exports) of Hungary in 1979?
Make the answer very short. 18.76. What is the difference between the Exports(as % of merchandise exports) in Germany in 1978 and the Exports(as % of merchandise exports) in Qatar in 1979?
Give a very brief answer. 81.19. What is the difference between the Exports(as % of merchandise exports) of Germany in 1978 and the Exports(as % of merchandise exports) of Thailand in 1979?
Give a very brief answer. 63.38. What is the difference between the Exports(as % of merchandise exports) of Hungary in 1978 and the Exports(as % of merchandise exports) of Qatar in 1979?
Offer a terse response. 63.07. What is the difference between the Exports(as % of merchandise exports) of Hungary in 1978 and the Exports(as % of merchandise exports) of Thailand in 1979?
Your answer should be compact. 45.26. What is the difference between the Exports(as % of merchandise exports) in Qatar in 1978 and the Exports(as % of merchandise exports) in Thailand in 1979?
Offer a terse response. -19.91. What is the average Exports(as % of merchandise exports) of Germany per year?
Your answer should be very brief. 86.68. What is the average Exports(as % of merchandise exports) in Hungary per year?
Offer a very short reply. 34.75. What is the average Exports(as % of merchandise exports) in Qatar per year?
Offer a terse response. 2.6. What is the average Exports(as % of merchandise exports) in Thailand per year?
Offer a terse response. 16.58. In the year 1972, what is the difference between the Exports(as % of merchandise exports) of Germany and Exports(as % of merchandise exports) of Hungary?
Keep it short and to the point. 77.85. In the year 1972, what is the difference between the Exports(as % of merchandise exports) of Germany and Exports(as % of merchandise exports) of Qatar?
Your answer should be compact. 86.18. In the year 1972, what is the difference between the Exports(as % of merchandise exports) of Germany and Exports(as % of merchandise exports) of Thailand?
Give a very brief answer. 78.11. In the year 1972, what is the difference between the Exports(as % of merchandise exports) in Hungary and Exports(as % of merchandise exports) in Qatar?
Give a very brief answer. 8.33. In the year 1972, what is the difference between the Exports(as % of merchandise exports) in Hungary and Exports(as % of merchandise exports) in Thailand?
Your answer should be very brief. 0.26. In the year 1972, what is the difference between the Exports(as % of merchandise exports) in Qatar and Exports(as % of merchandise exports) in Thailand?
Give a very brief answer. -8.07. In the year 1973, what is the difference between the Exports(as % of merchandise exports) in Germany and Exports(as % of merchandise exports) in Hungary?
Provide a succinct answer. 77.69. In the year 1973, what is the difference between the Exports(as % of merchandise exports) in Germany and Exports(as % of merchandise exports) in Qatar?
Keep it short and to the point. 85.98. In the year 1973, what is the difference between the Exports(as % of merchandise exports) in Germany and Exports(as % of merchandise exports) in Thailand?
Your answer should be compact. 72.02. In the year 1973, what is the difference between the Exports(as % of merchandise exports) of Hungary and Exports(as % of merchandise exports) of Qatar?
Provide a succinct answer. 8.29. In the year 1973, what is the difference between the Exports(as % of merchandise exports) in Hungary and Exports(as % of merchandise exports) in Thailand?
Offer a very short reply. -5.67. In the year 1973, what is the difference between the Exports(as % of merchandise exports) of Qatar and Exports(as % of merchandise exports) of Thailand?
Your response must be concise. -13.96. In the year 1974, what is the difference between the Exports(as % of merchandise exports) in Germany and Exports(as % of merchandise exports) in Hungary?
Make the answer very short. 75.74. In the year 1974, what is the difference between the Exports(as % of merchandise exports) in Germany and Exports(as % of merchandise exports) in Qatar?
Offer a very short reply. 83.89. In the year 1974, what is the difference between the Exports(as % of merchandise exports) of Germany and Exports(as % of merchandise exports) of Thailand?
Ensure brevity in your answer.  71.66. In the year 1974, what is the difference between the Exports(as % of merchandise exports) of Hungary and Exports(as % of merchandise exports) of Qatar?
Your answer should be very brief. 8.15. In the year 1974, what is the difference between the Exports(as % of merchandise exports) of Hungary and Exports(as % of merchandise exports) of Thailand?
Offer a very short reply. -4.08. In the year 1974, what is the difference between the Exports(as % of merchandise exports) in Qatar and Exports(as % of merchandise exports) in Thailand?
Make the answer very short. -12.23. In the year 1975, what is the difference between the Exports(as % of merchandise exports) in Germany and Exports(as % of merchandise exports) in Hungary?
Provide a short and direct response. 77.02. In the year 1975, what is the difference between the Exports(as % of merchandise exports) in Germany and Exports(as % of merchandise exports) in Qatar?
Provide a succinct answer. 83.63. In the year 1975, what is the difference between the Exports(as % of merchandise exports) of Germany and Exports(as % of merchandise exports) of Thailand?
Provide a short and direct response. 71.55. In the year 1975, what is the difference between the Exports(as % of merchandise exports) in Hungary and Exports(as % of merchandise exports) in Qatar?
Your response must be concise. 6.61. In the year 1975, what is the difference between the Exports(as % of merchandise exports) of Hungary and Exports(as % of merchandise exports) of Thailand?
Ensure brevity in your answer.  -5.47. In the year 1975, what is the difference between the Exports(as % of merchandise exports) of Qatar and Exports(as % of merchandise exports) of Thailand?
Give a very brief answer. -12.08. In the year 1976, what is the difference between the Exports(as % of merchandise exports) in Germany and Exports(as % of merchandise exports) in Hungary?
Ensure brevity in your answer.  19.03. In the year 1976, what is the difference between the Exports(as % of merchandise exports) of Germany and Exports(as % of merchandise exports) of Qatar?
Offer a very short reply. 85.09. In the year 1976, what is the difference between the Exports(as % of merchandise exports) of Germany and Exports(as % of merchandise exports) of Thailand?
Make the answer very short. 69.82. In the year 1976, what is the difference between the Exports(as % of merchandise exports) in Hungary and Exports(as % of merchandise exports) in Qatar?
Offer a terse response. 66.06. In the year 1976, what is the difference between the Exports(as % of merchandise exports) of Hungary and Exports(as % of merchandise exports) of Thailand?
Offer a terse response. 50.79. In the year 1976, what is the difference between the Exports(as % of merchandise exports) of Qatar and Exports(as % of merchandise exports) of Thailand?
Give a very brief answer. -15.28. In the year 1978, what is the difference between the Exports(as % of merchandise exports) of Germany and Exports(as % of merchandise exports) of Hungary?
Give a very brief answer. 18.12. In the year 1978, what is the difference between the Exports(as % of merchandise exports) of Germany and Exports(as % of merchandise exports) of Qatar?
Offer a very short reply. 83.3. In the year 1978, what is the difference between the Exports(as % of merchandise exports) in Germany and Exports(as % of merchandise exports) in Thailand?
Keep it short and to the point. 64.9. In the year 1978, what is the difference between the Exports(as % of merchandise exports) in Hungary and Exports(as % of merchandise exports) in Qatar?
Your answer should be very brief. 65.18. In the year 1978, what is the difference between the Exports(as % of merchandise exports) of Hungary and Exports(as % of merchandise exports) of Thailand?
Provide a short and direct response. 46.78. In the year 1978, what is the difference between the Exports(as % of merchandise exports) in Qatar and Exports(as % of merchandise exports) in Thailand?
Keep it short and to the point. -18.39. In the year 1979, what is the difference between the Exports(as % of merchandise exports) of Germany and Exports(as % of merchandise exports) of Hungary?
Offer a terse response. 18.07. In the year 1979, what is the difference between the Exports(as % of merchandise exports) of Germany and Exports(as % of merchandise exports) of Qatar?
Your answer should be compact. 80.5. In the year 1979, what is the difference between the Exports(as % of merchandise exports) of Germany and Exports(as % of merchandise exports) of Thailand?
Offer a terse response. 62.69. In the year 1979, what is the difference between the Exports(as % of merchandise exports) of Hungary and Exports(as % of merchandise exports) of Qatar?
Your response must be concise. 62.43. In the year 1979, what is the difference between the Exports(as % of merchandise exports) of Hungary and Exports(as % of merchandise exports) of Thailand?
Offer a very short reply. 44.62. In the year 1979, what is the difference between the Exports(as % of merchandise exports) of Qatar and Exports(as % of merchandise exports) of Thailand?
Offer a terse response. -17.81. What is the ratio of the Exports(as % of merchandise exports) in Germany in 1972 to that in 1973?
Give a very brief answer. 1.01. What is the ratio of the Exports(as % of merchandise exports) in Hungary in 1972 to that in 1973?
Offer a very short reply. 1.04. What is the ratio of the Exports(as % of merchandise exports) of Qatar in 1972 to that in 1973?
Give a very brief answer. 1.2. What is the ratio of the Exports(as % of merchandise exports) of Thailand in 1972 to that in 1973?
Your answer should be compact. 0.66. What is the ratio of the Exports(as % of merchandise exports) of Germany in 1972 to that in 1974?
Offer a terse response. 1.04. What is the ratio of the Exports(as % of merchandise exports) in Hungary in 1972 to that in 1974?
Give a very brief answer. 1.11. What is the ratio of the Exports(as % of merchandise exports) of Qatar in 1972 to that in 1974?
Provide a succinct answer. 1.59. What is the ratio of the Exports(as % of merchandise exports) of Thailand in 1972 to that in 1974?
Provide a succinct answer. 0.76. What is the ratio of the Exports(as % of merchandise exports) of Germany in 1972 to that in 1975?
Offer a terse response. 1.03. What is the ratio of the Exports(as % of merchandise exports) of Hungary in 1972 to that in 1975?
Provide a short and direct response. 1.17. What is the ratio of the Exports(as % of merchandise exports) in Qatar in 1972 to that in 1975?
Keep it short and to the point. 0.94. What is the ratio of the Exports(as % of merchandise exports) of Thailand in 1972 to that in 1975?
Keep it short and to the point. 0.72. What is the ratio of the Exports(as % of merchandise exports) in Germany in 1972 to that in 1976?
Offer a terse response. 1.02. What is the ratio of the Exports(as % of merchandise exports) in Hungary in 1972 to that in 1976?
Keep it short and to the point. 0.16. What is the ratio of the Exports(as % of merchandise exports) in Qatar in 1972 to that in 1976?
Your answer should be very brief. 1.73. What is the ratio of the Exports(as % of merchandise exports) in Thailand in 1972 to that in 1976?
Keep it short and to the point. 0.63. What is the ratio of the Exports(as % of merchandise exports) in Germany in 1972 to that in 1978?
Offer a terse response. 1.03. What is the ratio of the Exports(as % of merchandise exports) in Hungary in 1972 to that in 1978?
Keep it short and to the point. 0.16. What is the ratio of the Exports(as % of merchandise exports) of Qatar in 1972 to that in 1978?
Your response must be concise. 0.8. What is the ratio of the Exports(as % of merchandise exports) in Thailand in 1972 to that in 1978?
Offer a terse response. 0.49. What is the ratio of the Exports(as % of merchandise exports) in Germany in 1972 to that in 1979?
Provide a short and direct response. 1.03. What is the ratio of the Exports(as % of merchandise exports) of Hungary in 1972 to that in 1979?
Offer a very short reply. 0.16. What is the ratio of the Exports(as % of merchandise exports) of Qatar in 1972 to that in 1979?
Your response must be concise. 0.47. What is the ratio of the Exports(as % of merchandise exports) of Thailand in 1972 to that in 1979?
Offer a terse response. 0.46. What is the ratio of the Exports(as % of merchandise exports) in Germany in 1973 to that in 1974?
Offer a terse response. 1.03. What is the ratio of the Exports(as % of merchandise exports) of Hungary in 1973 to that in 1974?
Ensure brevity in your answer.  1.07. What is the ratio of the Exports(as % of merchandise exports) of Qatar in 1973 to that in 1974?
Ensure brevity in your answer.  1.33. What is the ratio of the Exports(as % of merchandise exports) of Thailand in 1973 to that in 1974?
Keep it short and to the point. 1.16. What is the ratio of the Exports(as % of merchandise exports) of Germany in 1973 to that in 1975?
Ensure brevity in your answer.  1.02. What is the ratio of the Exports(as % of merchandise exports) in Hungary in 1973 to that in 1975?
Keep it short and to the point. 1.12. What is the ratio of the Exports(as % of merchandise exports) in Qatar in 1973 to that in 1975?
Give a very brief answer. 0.78. What is the ratio of the Exports(as % of merchandise exports) in Thailand in 1973 to that in 1975?
Offer a very short reply. 1.09. What is the ratio of the Exports(as % of merchandise exports) in Germany in 1973 to that in 1976?
Your response must be concise. 1.02. What is the ratio of the Exports(as % of merchandise exports) in Hungary in 1973 to that in 1976?
Provide a succinct answer. 0.15. What is the ratio of the Exports(as % of merchandise exports) of Qatar in 1973 to that in 1976?
Your answer should be compact. 1.44. What is the ratio of the Exports(as % of merchandise exports) in Thailand in 1973 to that in 1976?
Your answer should be compact. 0.96. What is the ratio of the Exports(as % of merchandise exports) of Germany in 1973 to that in 1978?
Give a very brief answer. 1.02. What is the ratio of the Exports(as % of merchandise exports) of Hungary in 1973 to that in 1978?
Your answer should be compact. 0.15. What is the ratio of the Exports(as % of merchandise exports) in Qatar in 1973 to that in 1978?
Give a very brief answer. 0.67. What is the ratio of the Exports(as % of merchandise exports) in Thailand in 1973 to that in 1978?
Provide a succinct answer. 0.75. What is the ratio of the Exports(as % of merchandise exports) of Germany in 1973 to that in 1979?
Ensure brevity in your answer.  1.03. What is the ratio of the Exports(as % of merchandise exports) in Hungary in 1973 to that in 1979?
Offer a terse response. 0.15. What is the ratio of the Exports(as % of merchandise exports) of Qatar in 1973 to that in 1979?
Keep it short and to the point. 0.4. What is the ratio of the Exports(as % of merchandise exports) in Thailand in 1973 to that in 1979?
Provide a succinct answer. 0.7. What is the ratio of the Exports(as % of merchandise exports) of Hungary in 1974 to that in 1975?
Ensure brevity in your answer.  1.05. What is the ratio of the Exports(as % of merchandise exports) in Qatar in 1974 to that in 1975?
Offer a terse response. 0.59. What is the ratio of the Exports(as % of merchandise exports) in Thailand in 1974 to that in 1975?
Offer a very short reply. 0.94. What is the ratio of the Exports(as % of merchandise exports) in Germany in 1974 to that in 1976?
Make the answer very short. 0.99. What is the ratio of the Exports(as % of merchandise exports) of Hungary in 1974 to that in 1976?
Make the answer very short. 0.14. What is the ratio of the Exports(as % of merchandise exports) of Qatar in 1974 to that in 1976?
Offer a very short reply. 1.09. What is the ratio of the Exports(as % of merchandise exports) of Thailand in 1974 to that in 1976?
Make the answer very short. 0.82. What is the ratio of the Exports(as % of merchandise exports) of Germany in 1974 to that in 1978?
Keep it short and to the point. 0.99. What is the ratio of the Exports(as % of merchandise exports) in Hungary in 1974 to that in 1978?
Ensure brevity in your answer.  0.14. What is the ratio of the Exports(as % of merchandise exports) of Qatar in 1974 to that in 1978?
Provide a short and direct response. 0.5. What is the ratio of the Exports(as % of merchandise exports) of Thailand in 1974 to that in 1978?
Your answer should be compact. 0.64. What is the ratio of the Exports(as % of merchandise exports) of Hungary in 1974 to that in 1979?
Offer a terse response. 0.14. What is the ratio of the Exports(as % of merchandise exports) in Qatar in 1974 to that in 1979?
Ensure brevity in your answer.  0.3. What is the ratio of the Exports(as % of merchandise exports) in Thailand in 1974 to that in 1979?
Offer a terse response. 0.6. What is the ratio of the Exports(as % of merchandise exports) in Germany in 1975 to that in 1976?
Keep it short and to the point. 1. What is the ratio of the Exports(as % of merchandise exports) in Hungary in 1975 to that in 1976?
Your response must be concise. 0.14. What is the ratio of the Exports(as % of merchandise exports) of Qatar in 1975 to that in 1976?
Ensure brevity in your answer.  1.84. What is the ratio of the Exports(as % of merchandise exports) in Thailand in 1975 to that in 1976?
Make the answer very short. 0.88. What is the ratio of the Exports(as % of merchandise exports) in Hungary in 1975 to that in 1978?
Make the answer very short. 0.14. What is the ratio of the Exports(as % of merchandise exports) of Qatar in 1975 to that in 1978?
Provide a short and direct response. 0.85. What is the ratio of the Exports(as % of merchandise exports) of Thailand in 1975 to that in 1978?
Offer a very short reply. 0.68. What is the ratio of the Exports(as % of merchandise exports) of Germany in 1975 to that in 1979?
Your answer should be compact. 1.01. What is the ratio of the Exports(as % of merchandise exports) in Hungary in 1975 to that in 1979?
Offer a terse response. 0.14. What is the ratio of the Exports(as % of merchandise exports) of Qatar in 1975 to that in 1979?
Provide a short and direct response. 0.5. What is the ratio of the Exports(as % of merchandise exports) in Thailand in 1975 to that in 1979?
Make the answer very short. 0.64. What is the ratio of the Exports(as % of merchandise exports) in Germany in 1976 to that in 1978?
Your answer should be very brief. 1. What is the ratio of the Exports(as % of merchandise exports) of Qatar in 1976 to that in 1978?
Provide a succinct answer. 0.46. What is the ratio of the Exports(as % of merchandise exports) in Thailand in 1976 to that in 1978?
Provide a succinct answer. 0.78. What is the ratio of the Exports(as % of merchandise exports) of Germany in 1976 to that in 1979?
Offer a very short reply. 1.01. What is the ratio of the Exports(as % of merchandise exports) of Qatar in 1976 to that in 1979?
Your answer should be very brief. 0.27. What is the ratio of the Exports(as % of merchandise exports) in Thailand in 1976 to that in 1979?
Ensure brevity in your answer.  0.73. What is the ratio of the Exports(as % of merchandise exports) in Hungary in 1978 to that in 1979?
Provide a short and direct response. 1.01. What is the ratio of the Exports(as % of merchandise exports) of Qatar in 1978 to that in 1979?
Provide a succinct answer. 0.59. What is the ratio of the Exports(as % of merchandise exports) of Thailand in 1978 to that in 1979?
Your answer should be compact. 0.93. What is the difference between the highest and the second highest Exports(as % of merchandise exports) in Germany?
Offer a very short reply. 0.6. What is the difference between the highest and the second highest Exports(as % of merchandise exports) in Hungary?
Your answer should be compact. 0.64. What is the difference between the highest and the second highest Exports(as % of merchandise exports) in Qatar?
Make the answer very short. 2.1. What is the difference between the highest and the second highest Exports(as % of merchandise exports) in Thailand?
Offer a terse response. 1.52. What is the difference between the highest and the lowest Exports(as % of merchandise exports) of Germany?
Ensure brevity in your answer.  3.2. What is the difference between the highest and the lowest Exports(as % of merchandise exports) of Hungary?
Give a very brief answer. 59.02. What is the difference between the highest and the lowest Exports(as % of merchandise exports) of Qatar?
Your answer should be compact. 3.74. What is the difference between the highest and the lowest Exports(as % of merchandise exports) of Thailand?
Provide a succinct answer. 12.46. 